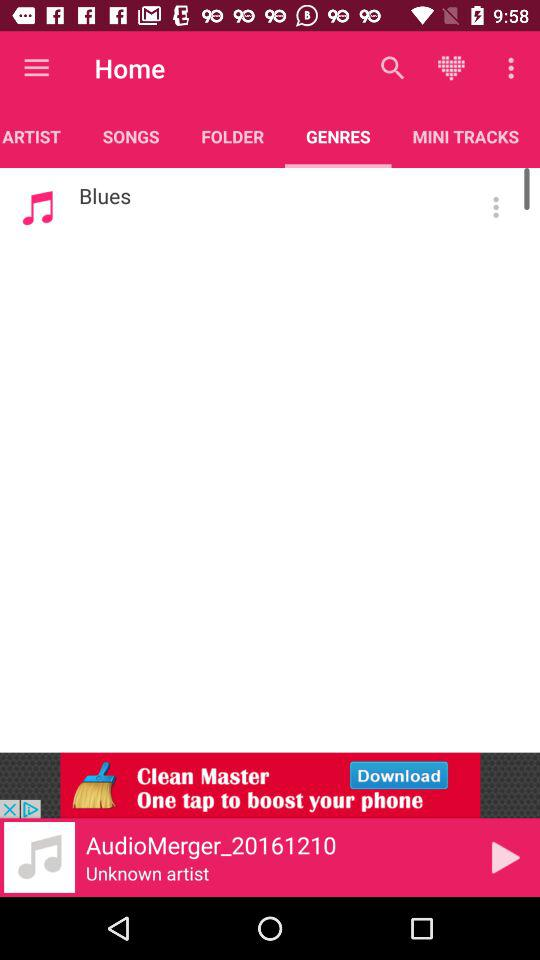Which songs do I have in my genres? The song in your genre is Blues. 